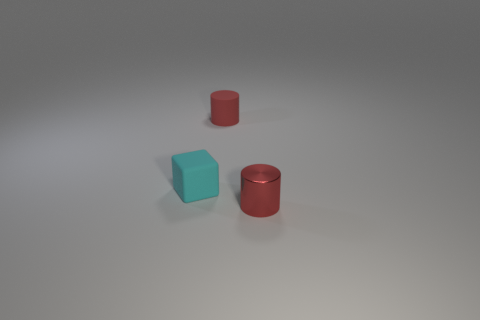There is a object that is to the right of the cyan rubber cube and in front of the small red matte object; what is its material?
Provide a short and direct response. Metal. Is the color of the cylinder behind the metal thing the same as the metallic cylinder?
Give a very brief answer. Yes. Do the matte cube and the tiny cylinder that is behind the small metallic cylinder have the same color?
Make the answer very short. No. There is a cyan block; are there any red rubber things behind it?
Provide a succinct answer. Yes. There is another cylinder that is the same size as the red rubber cylinder; what is its material?
Offer a very short reply. Metal. How many things are either red things in front of the cyan object or gray rubber cylinders?
Make the answer very short. 1. Is the number of shiny things that are right of the small red metallic thing the same as the number of small yellow metallic blocks?
Give a very brief answer. Yes. Does the small rubber cylinder have the same color as the small shiny thing?
Give a very brief answer. Yes. The thing that is both on the left side of the small red shiny cylinder and in front of the small red rubber cylinder is what color?
Your answer should be compact. Cyan. How many cylinders are tiny red metal objects or tiny matte objects?
Provide a short and direct response. 2. 